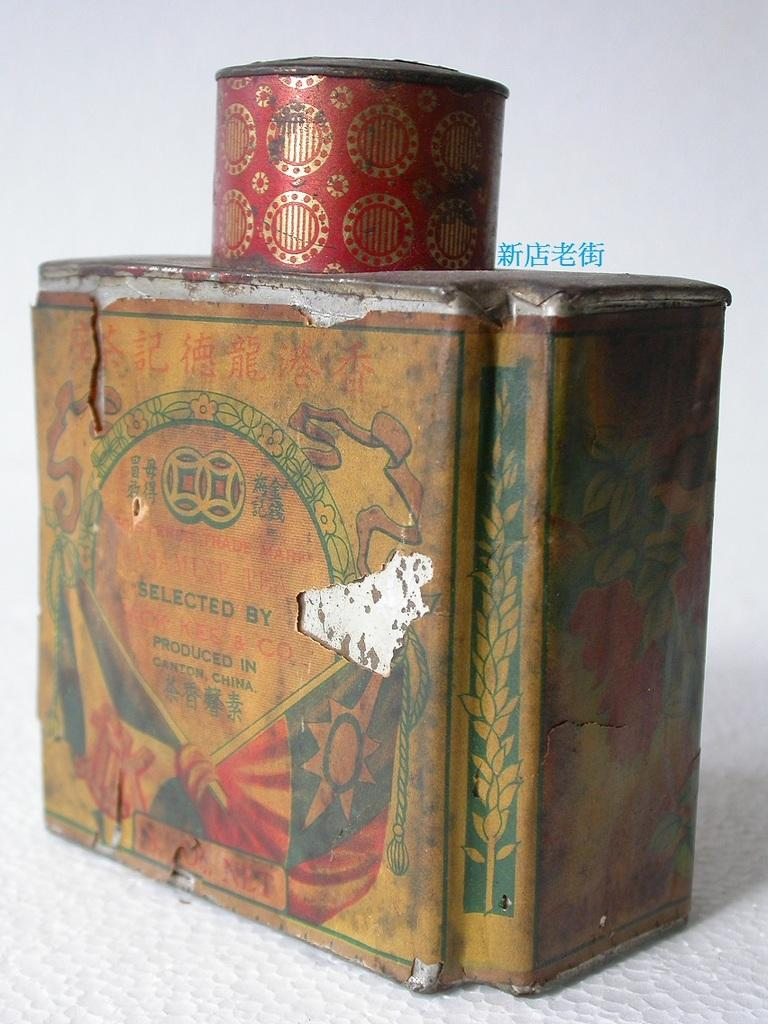Provide a one-sentence caption for the provided image. Jasmine Tea once was inside the vintage Asian tin. 